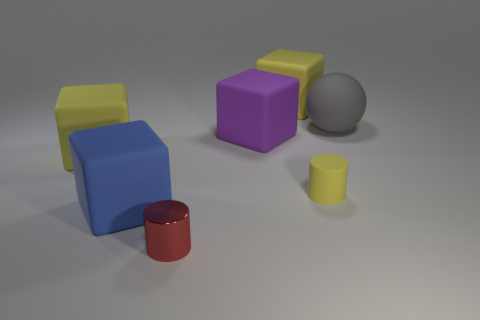Can you guess the material these objects might be made of? The objects in the image appear to have a smooth surface with a slight reflection, suggesting that they could be made of plastic or a similar material with a matte finish. 